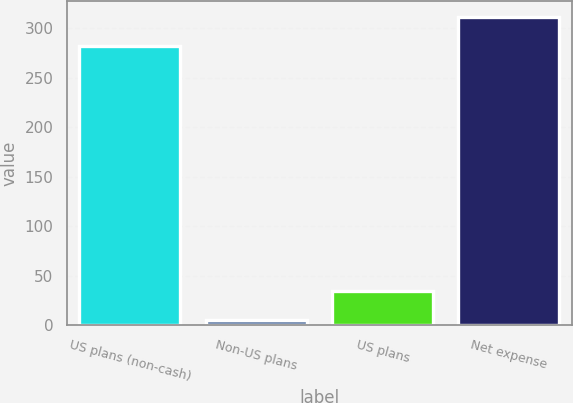<chart> <loc_0><loc_0><loc_500><loc_500><bar_chart><fcel>US plans (non-cash)<fcel>Non-US plans<fcel>US plans<fcel>Net expense<nl><fcel>282<fcel>5<fcel>34.6<fcel>311.6<nl></chart> 